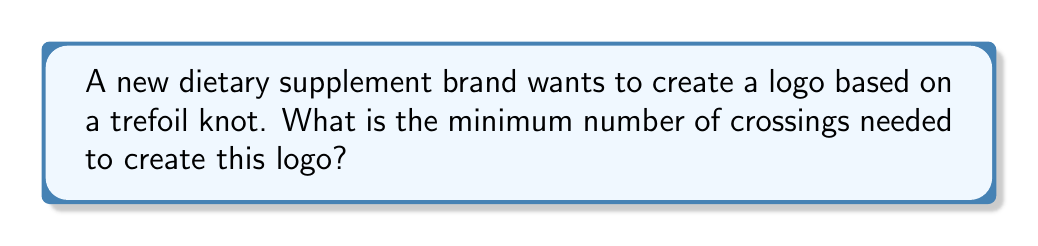Give your solution to this math problem. To determine the minimum number of crossings for a trefoil knot logo, we need to consider the following steps:

1. Recall that a trefoil knot is the simplest non-trivial knot in knot theory.

2. The trefoil knot is classified as a $(2,3)$-torus knot, which means it wraps around a torus 2 times in one direction and 3 times in the other.

3. The crossing number of a $(p,q)$-torus knot, where $p$ and $q$ are coprime, is given by the formula:

   $$c(T_{p,q}) = \min(p(q-1), q(p-1))$$

4. For the trefoil knot, we have $p=2$ and $q=3$. Let's substitute these values:

   $$c(T_{2,3}) = \min(2(3-1), 3(2-1))$$
   $$c(T_{2,3}) = \min(2(2), 3(1))$$
   $$c(T_{2,3}) = \min(4, 3)$$

5. The minimum of 4 and 3 is 3.

Therefore, the minimum number of crossings needed to create a logo based on a trefoil knot is 3.

[asy]
import geometry;

size(100);
path p = (0,0)..(-1,1)..(0,2)..(1,1)..(0,0);
path q = p rotated 120;
path r = p rotated 240;

draw(p);
draw(q);
draw(r);

dot((0,0), filltype=Fill(white));
dot((-sqrt(3)/2, 1/2), filltype=Fill(white));
dot((sqrt(3)/2, 1/2), filltype=Fill(white));
[/asy]
Answer: 3 crossings 